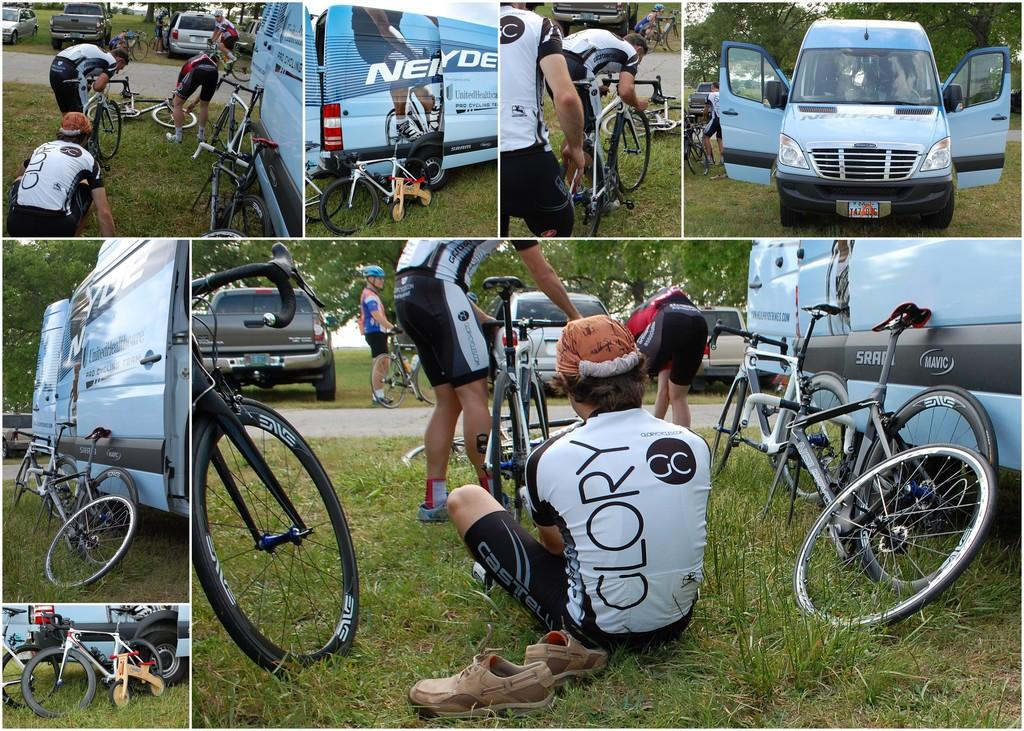What is the person in the image doing? The person is sitting on the floor in the image. What else can be seen in the image besides the person? There are bicycles in the image. What type of bead is being used to set off the alarm in the image? There is no bead or alarm present in the image. What color is the person's lipstick in the image? There is no mention of lipstick or any cosmetics in the image. 